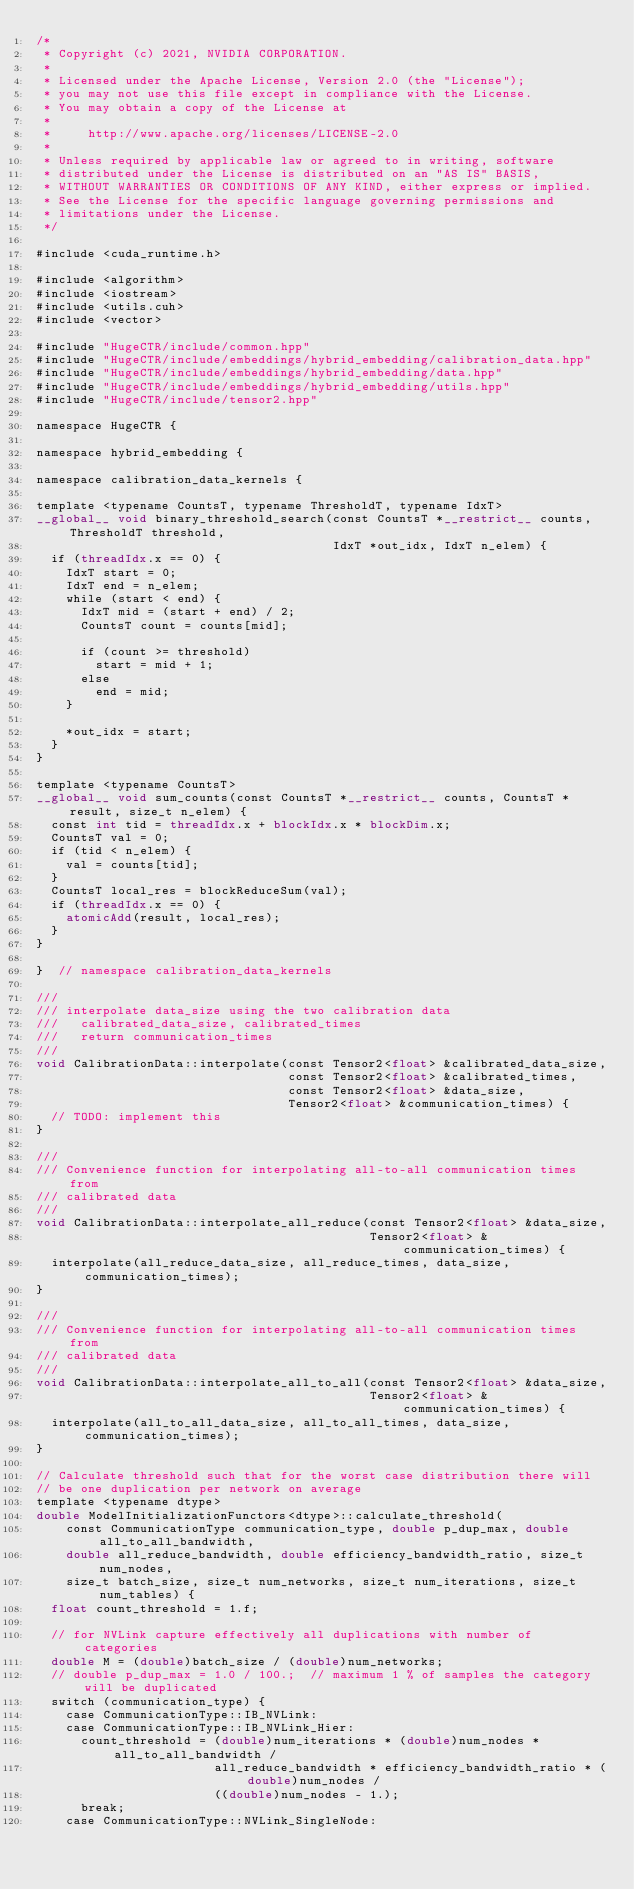<code> <loc_0><loc_0><loc_500><loc_500><_Cuda_>/*
 * Copyright (c) 2021, NVIDIA CORPORATION.
 *
 * Licensed under the Apache License, Version 2.0 (the "License");
 * you may not use this file except in compliance with the License.
 * You may obtain a copy of the License at
 *
 *     http://www.apache.org/licenses/LICENSE-2.0
 *
 * Unless required by applicable law or agreed to in writing, software
 * distributed under the License is distributed on an "AS IS" BASIS,
 * WITHOUT WARRANTIES OR CONDITIONS OF ANY KIND, either express or implied.
 * See the License for the specific language governing permissions and
 * limitations under the License.
 */

#include <cuda_runtime.h>

#include <algorithm>
#include <iostream>
#include <utils.cuh>
#include <vector>

#include "HugeCTR/include/common.hpp"
#include "HugeCTR/include/embeddings/hybrid_embedding/calibration_data.hpp"
#include "HugeCTR/include/embeddings/hybrid_embedding/data.hpp"
#include "HugeCTR/include/embeddings/hybrid_embedding/utils.hpp"
#include "HugeCTR/include/tensor2.hpp"

namespace HugeCTR {

namespace hybrid_embedding {

namespace calibration_data_kernels {

template <typename CountsT, typename ThresholdT, typename IdxT>
__global__ void binary_threshold_search(const CountsT *__restrict__ counts, ThresholdT threshold,
                                        IdxT *out_idx, IdxT n_elem) {
  if (threadIdx.x == 0) {
    IdxT start = 0;
    IdxT end = n_elem;
    while (start < end) {
      IdxT mid = (start + end) / 2;
      CountsT count = counts[mid];

      if (count >= threshold)
        start = mid + 1;
      else
        end = mid;
    }

    *out_idx = start;
  }
}

template <typename CountsT>
__global__ void sum_counts(const CountsT *__restrict__ counts, CountsT *result, size_t n_elem) {
  const int tid = threadIdx.x + blockIdx.x * blockDim.x;
  CountsT val = 0;
  if (tid < n_elem) {
    val = counts[tid];
  }
  CountsT local_res = blockReduceSum(val);
  if (threadIdx.x == 0) {
    atomicAdd(result, local_res);
  }
}

}  // namespace calibration_data_kernels

///
/// interpolate data_size using the two calibration data
///   calibrated_data_size, calibrated_times
///   return communication_times
///
void CalibrationData::interpolate(const Tensor2<float> &calibrated_data_size,
                                  const Tensor2<float> &calibrated_times,
                                  const Tensor2<float> &data_size,
                                  Tensor2<float> &communication_times) {
  // TODO: implement this
}

///
/// Convenience function for interpolating all-to-all communication times from
/// calibrated data
///
void CalibrationData::interpolate_all_reduce(const Tensor2<float> &data_size,
                                             Tensor2<float> &communication_times) {
  interpolate(all_reduce_data_size, all_reduce_times, data_size, communication_times);
}

///
/// Convenience function for interpolating all-to-all communication times from
/// calibrated data
///
void CalibrationData::interpolate_all_to_all(const Tensor2<float> &data_size,
                                             Tensor2<float> &communication_times) {
  interpolate(all_to_all_data_size, all_to_all_times, data_size, communication_times);
}

// Calculate threshold such that for the worst case distribution there will
// be one duplication per network on average
template <typename dtype>
double ModelInitializationFunctors<dtype>::calculate_threshold(
    const CommunicationType communication_type, double p_dup_max, double all_to_all_bandwidth,
    double all_reduce_bandwidth, double efficiency_bandwidth_ratio, size_t num_nodes,
    size_t batch_size, size_t num_networks, size_t num_iterations, size_t num_tables) {
  float count_threshold = 1.f;

  // for NVLink capture effectively all duplications with number of categories
  double M = (double)batch_size / (double)num_networks;
  // double p_dup_max = 1.0 / 100.;  // maximum 1 % of samples the category will be duplicated
  switch (communication_type) {
    case CommunicationType::IB_NVLink:
    case CommunicationType::IB_NVLink_Hier:
      count_threshold = (double)num_iterations * (double)num_nodes * all_to_all_bandwidth /
                        all_reduce_bandwidth * efficiency_bandwidth_ratio * (double)num_nodes /
                        ((double)num_nodes - 1.);
      break;
    case CommunicationType::NVLink_SingleNode:</code> 